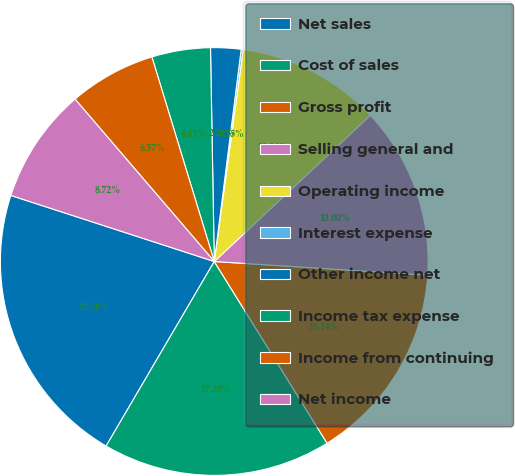Convert chart. <chart><loc_0><loc_0><loc_500><loc_500><pie_chart><fcel>Net sales<fcel>Cost of sales<fcel>Gross profit<fcel>Selling general and<fcel>Operating income<fcel>Interest expense<fcel>Other income net<fcel>Income tax expense<fcel>Income from continuing<fcel>Net income<nl><fcel>21.56%<fcel>17.28%<fcel>15.14%<fcel>13.0%<fcel>10.86%<fcel>0.15%<fcel>2.29%<fcel>4.43%<fcel>6.57%<fcel>8.72%<nl></chart> 